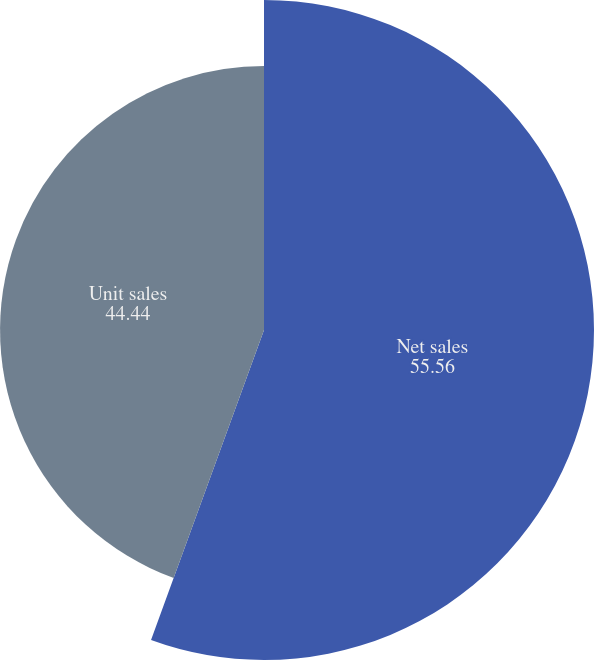Convert chart to OTSL. <chart><loc_0><loc_0><loc_500><loc_500><pie_chart><fcel>Net sales<fcel>Unit sales<nl><fcel>55.56%<fcel>44.44%<nl></chart> 